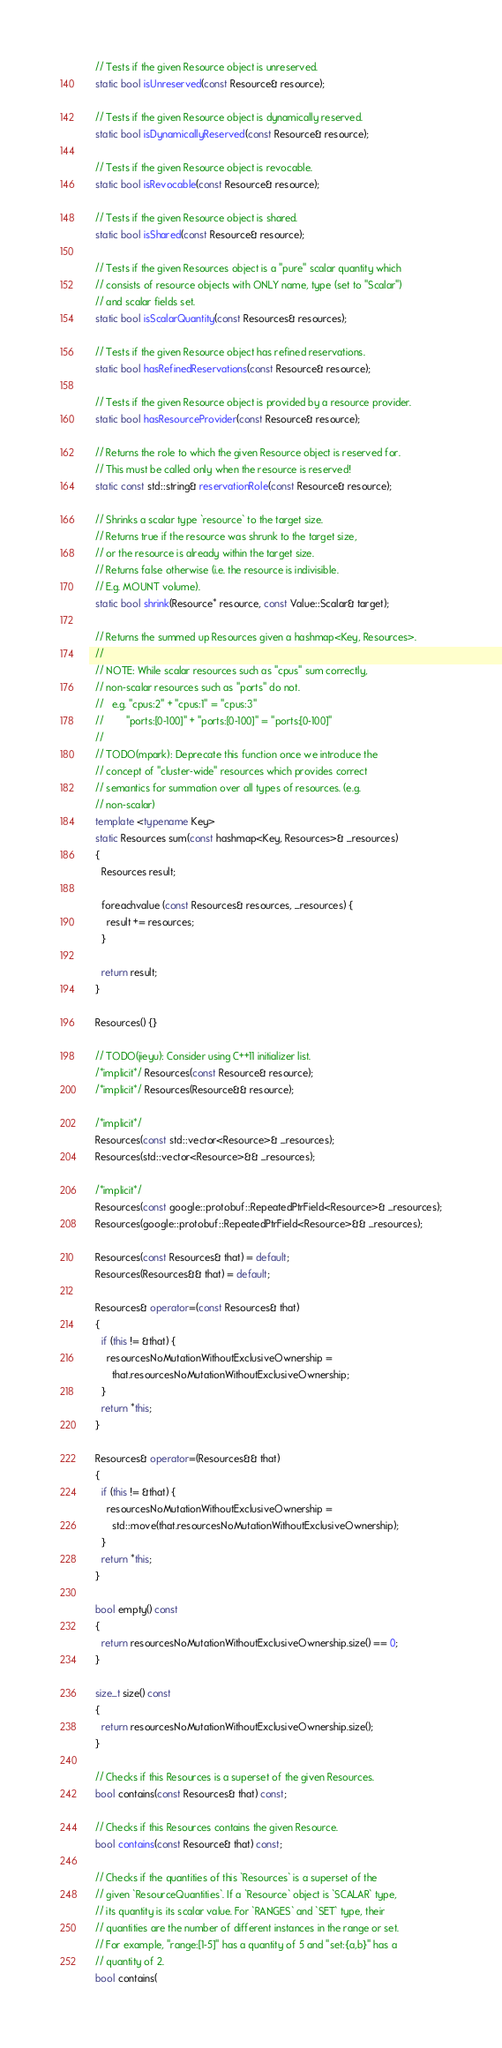Convert code to text. <code><loc_0><loc_0><loc_500><loc_500><_C++_>  // Tests if the given Resource object is unreserved.
  static bool isUnreserved(const Resource& resource);

  // Tests if the given Resource object is dynamically reserved.
  static bool isDynamicallyReserved(const Resource& resource);

  // Tests if the given Resource object is revocable.
  static bool isRevocable(const Resource& resource);

  // Tests if the given Resource object is shared.
  static bool isShared(const Resource& resource);

  // Tests if the given Resources object is a "pure" scalar quantity which
  // consists of resource objects with ONLY name, type (set to "Scalar")
  // and scalar fields set.
  static bool isScalarQuantity(const Resources& resources);

  // Tests if the given Resource object has refined reservations.
  static bool hasRefinedReservations(const Resource& resource);

  // Tests if the given Resource object is provided by a resource provider.
  static bool hasResourceProvider(const Resource& resource);

  // Returns the role to which the given Resource object is reserved for.
  // This must be called only when the resource is reserved!
  static const std::string& reservationRole(const Resource& resource);

  // Shrinks a scalar type `resource` to the target size.
  // Returns true if the resource was shrunk to the target size,
  // or the resource is already within the target size.
  // Returns false otherwise (i.e. the resource is indivisible.
  // E.g. MOUNT volume).
  static bool shrink(Resource* resource, const Value::Scalar& target);

  // Returns the summed up Resources given a hashmap<Key, Resources>.
  //
  // NOTE: While scalar resources such as "cpus" sum correctly,
  // non-scalar resources such as "ports" do not.
  //   e.g. "cpus:2" + "cpus:1" = "cpus:3"
  //        "ports:[0-100]" + "ports:[0-100]" = "ports:[0-100]"
  //
  // TODO(mpark): Deprecate this function once we introduce the
  // concept of "cluster-wide" resources which provides correct
  // semantics for summation over all types of resources. (e.g.
  // non-scalar)
  template <typename Key>
  static Resources sum(const hashmap<Key, Resources>& _resources)
  {
    Resources result;

    foreachvalue (const Resources& resources, _resources) {
      result += resources;
    }

    return result;
  }

  Resources() {}

  // TODO(jieyu): Consider using C++11 initializer list.
  /*implicit*/ Resources(const Resource& resource);
  /*implicit*/ Resources(Resource&& resource);

  /*implicit*/
  Resources(const std::vector<Resource>& _resources);
  Resources(std::vector<Resource>&& _resources);

  /*implicit*/
  Resources(const google::protobuf::RepeatedPtrField<Resource>& _resources);
  Resources(google::protobuf::RepeatedPtrField<Resource>&& _resources);

  Resources(const Resources& that) = default;
  Resources(Resources&& that) = default;

  Resources& operator=(const Resources& that)
  {
    if (this != &that) {
      resourcesNoMutationWithoutExclusiveOwnership =
        that.resourcesNoMutationWithoutExclusiveOwnership;
    }
    return *this;
  }

  Resources& operator=(Resources&& that)
  {
    if (this != &that) {
      resourcesNoMutationWithoutExclusiveOwnership =
        std::move(that.resourcesNoMutationWithoutExclusiveOwnership);
    }
    return *this;
  }

  bool empty() const
  {
    return resourcesNoMutationWithoutExclusiveOwnership.size() == 0;
  }

  size_t size() const
  {
    return resourcesNoMutationWithoutExclusiveOwnership.size();
  }

  // Checks if this Resources is a superset of the given Resources.
  bool contains(const Resources& that) const;

  // Checks if this Resources contains the given Resource.
  bool contains(const Resource& that) const;

  // Checks if the quantities of this `Resources` is a superset of the
  // given `ResourceQuantities`. If a `Resource` object is `SCALAR` type,
  // its quantity is its scalar value. For `RANGES` and `SET` type, their
  // quantities are the number of different instances in the range or set.
  // For example, "range:[1-5]" has a quantity of 5 and "set:{a,b}" has a
  // quantity of 2.
  bool contains(</code> 